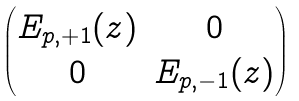<formula> <loc_0><loc_0><loc_500><loc_500>\begin{pmatrix} E _ { p , + 1 } ( z ) & 0 \\ 0 & E _ { p , - 1 } ( z ) \end{pmatrix}</formula> 